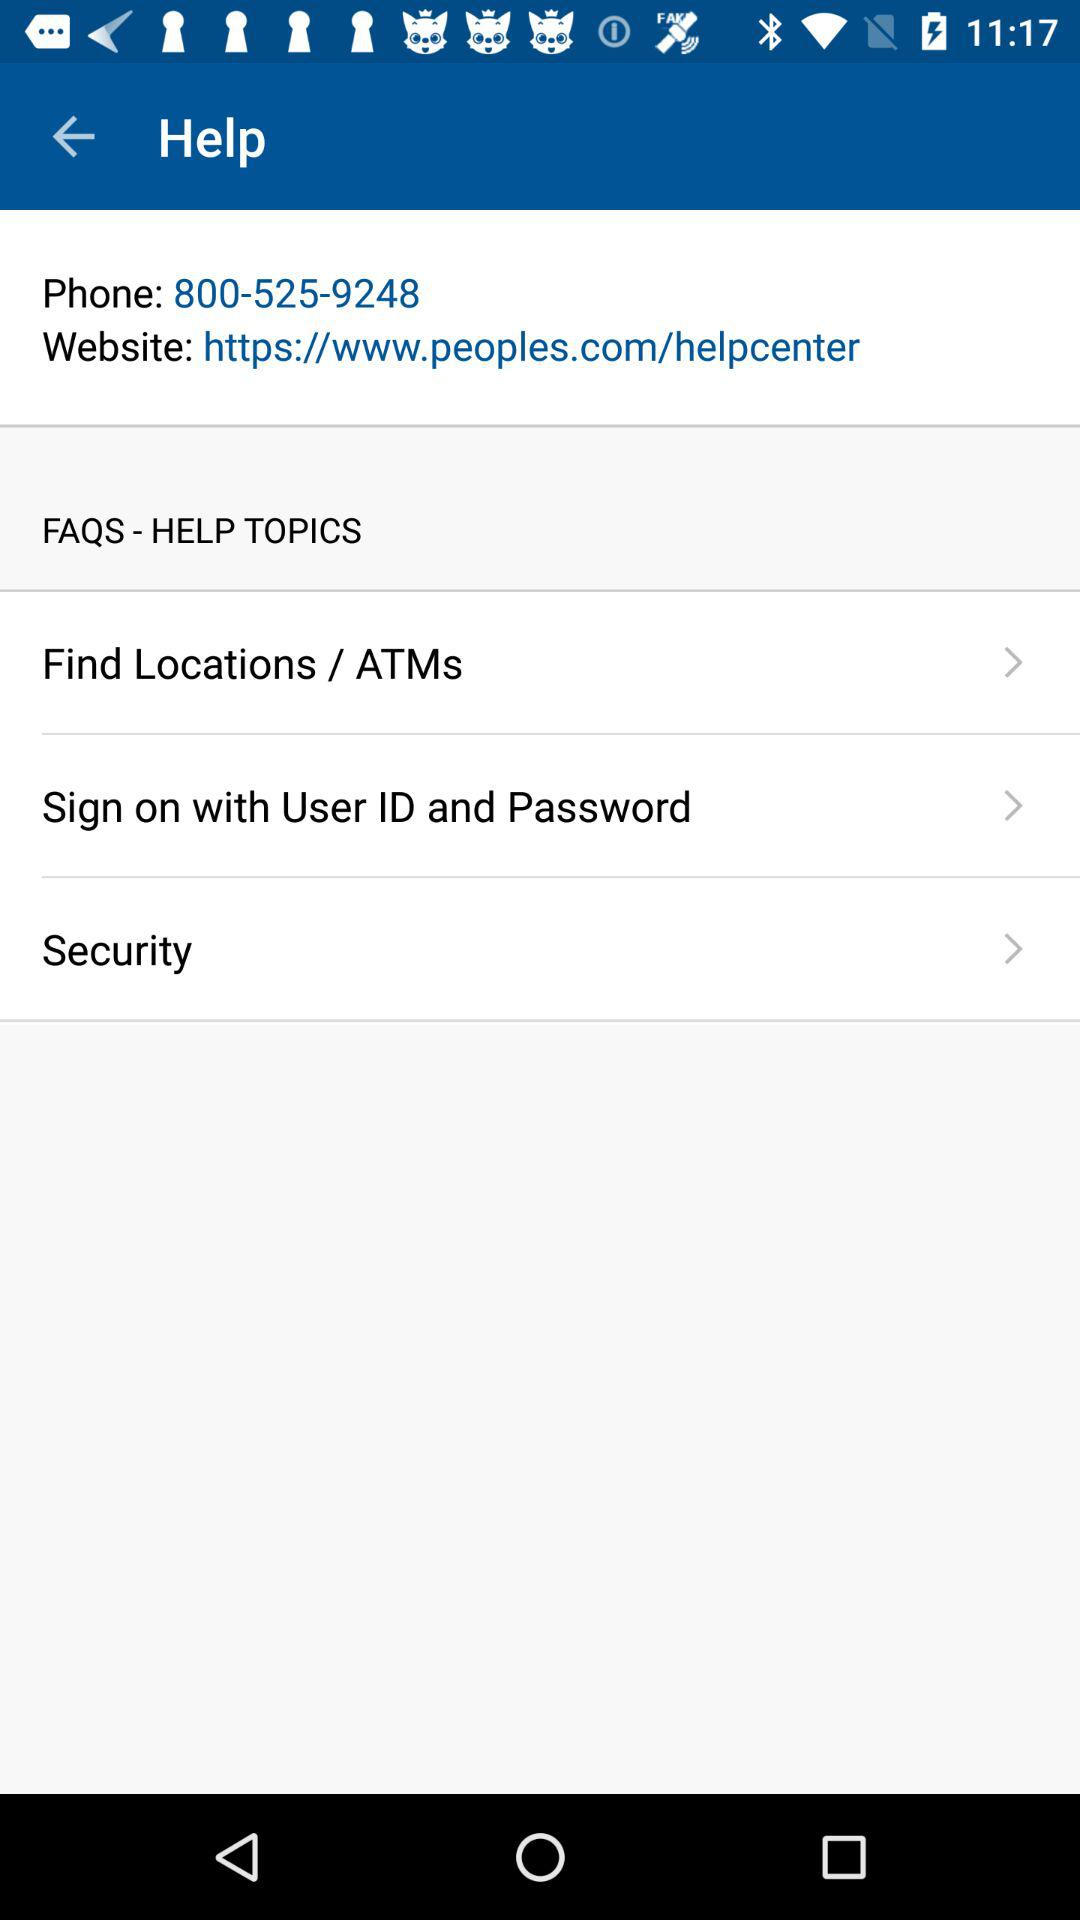What is the phone number? The phone number is 800-525-9248. 